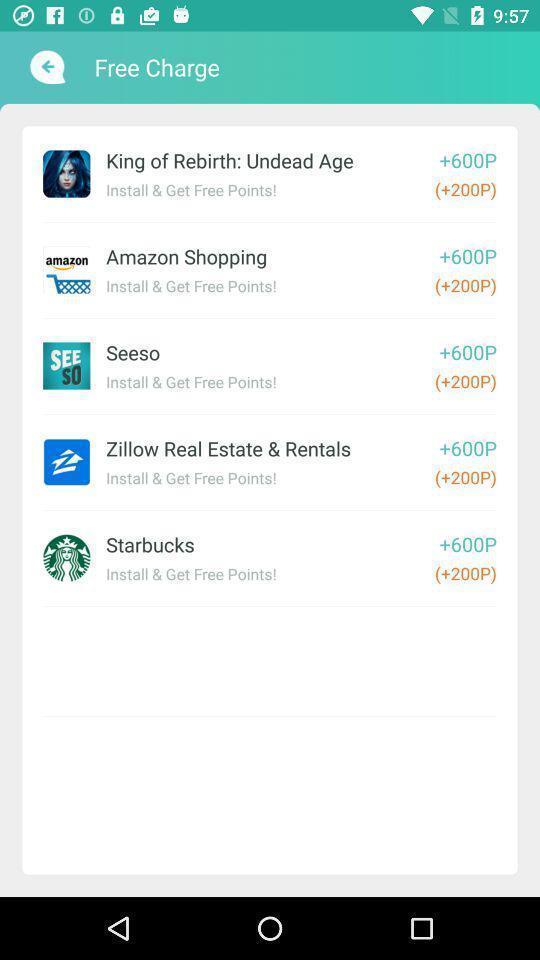Describe the key features of this screenshot. Screen shows details of free charge. 